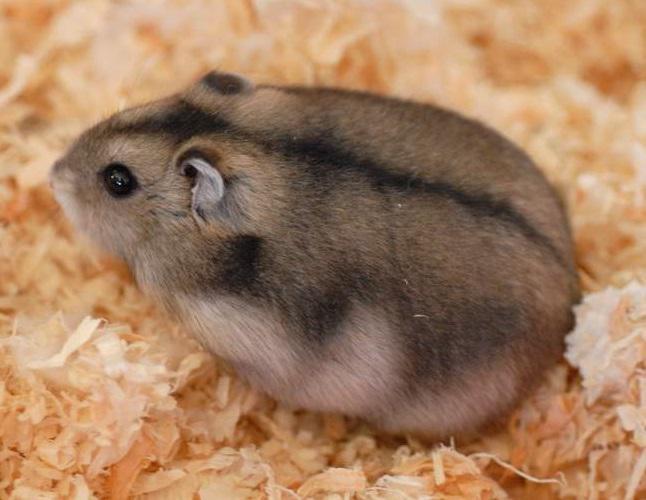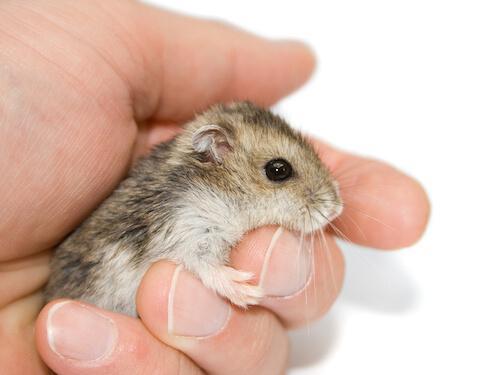The first image is the image on the left, the second image is the image on the right. Assess this claim about the two images: "One image shows at least one pet rodent on shredded bedding material, and the other image shows a hand holding no more than two pet rodents.". Correct or not? Answer yes or no. Yes. The first image is the image on the left, the second image is the image on the right. Examine the images to the left and right. Is the description "There are at least five animals in total." accurate? Answer yes or no. No. 